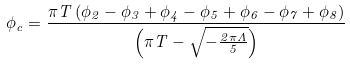Convert formula to latex. <formula><loc_0><loc_0><loc_500><loc_500>\phi _ { c } = \frac { \pi T \left ( \phi _ { 2 } - \phi _ { 3 } + \phi _ { 4 } - \phi _ { 5 } + \phi _ { 6 } - \phi _ { 7 } + \phi _ { 8 } \right ) } { \left ( \pi T - \sqrt { - \frac { 2 \pi \Lambda } { 5 } } \right ) }</formula> 